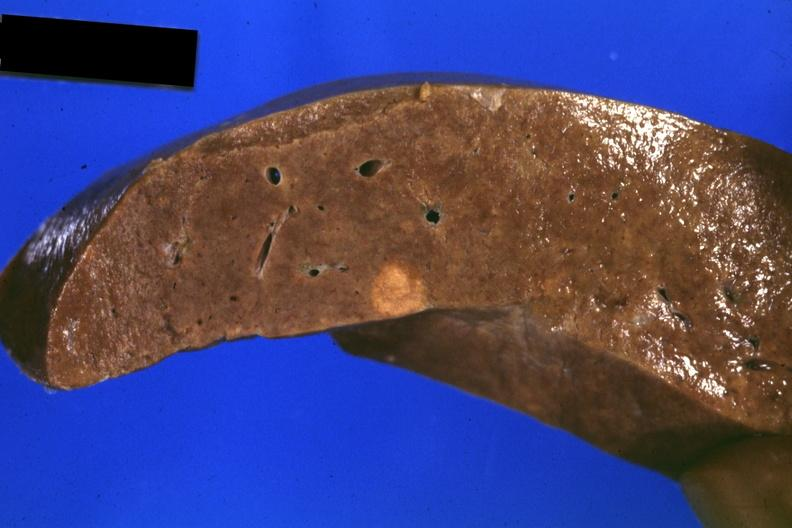does this good yellow color slide show fixed tissue close-up of tumor mass in liver?
Answer the question using a single word or phrase. No 